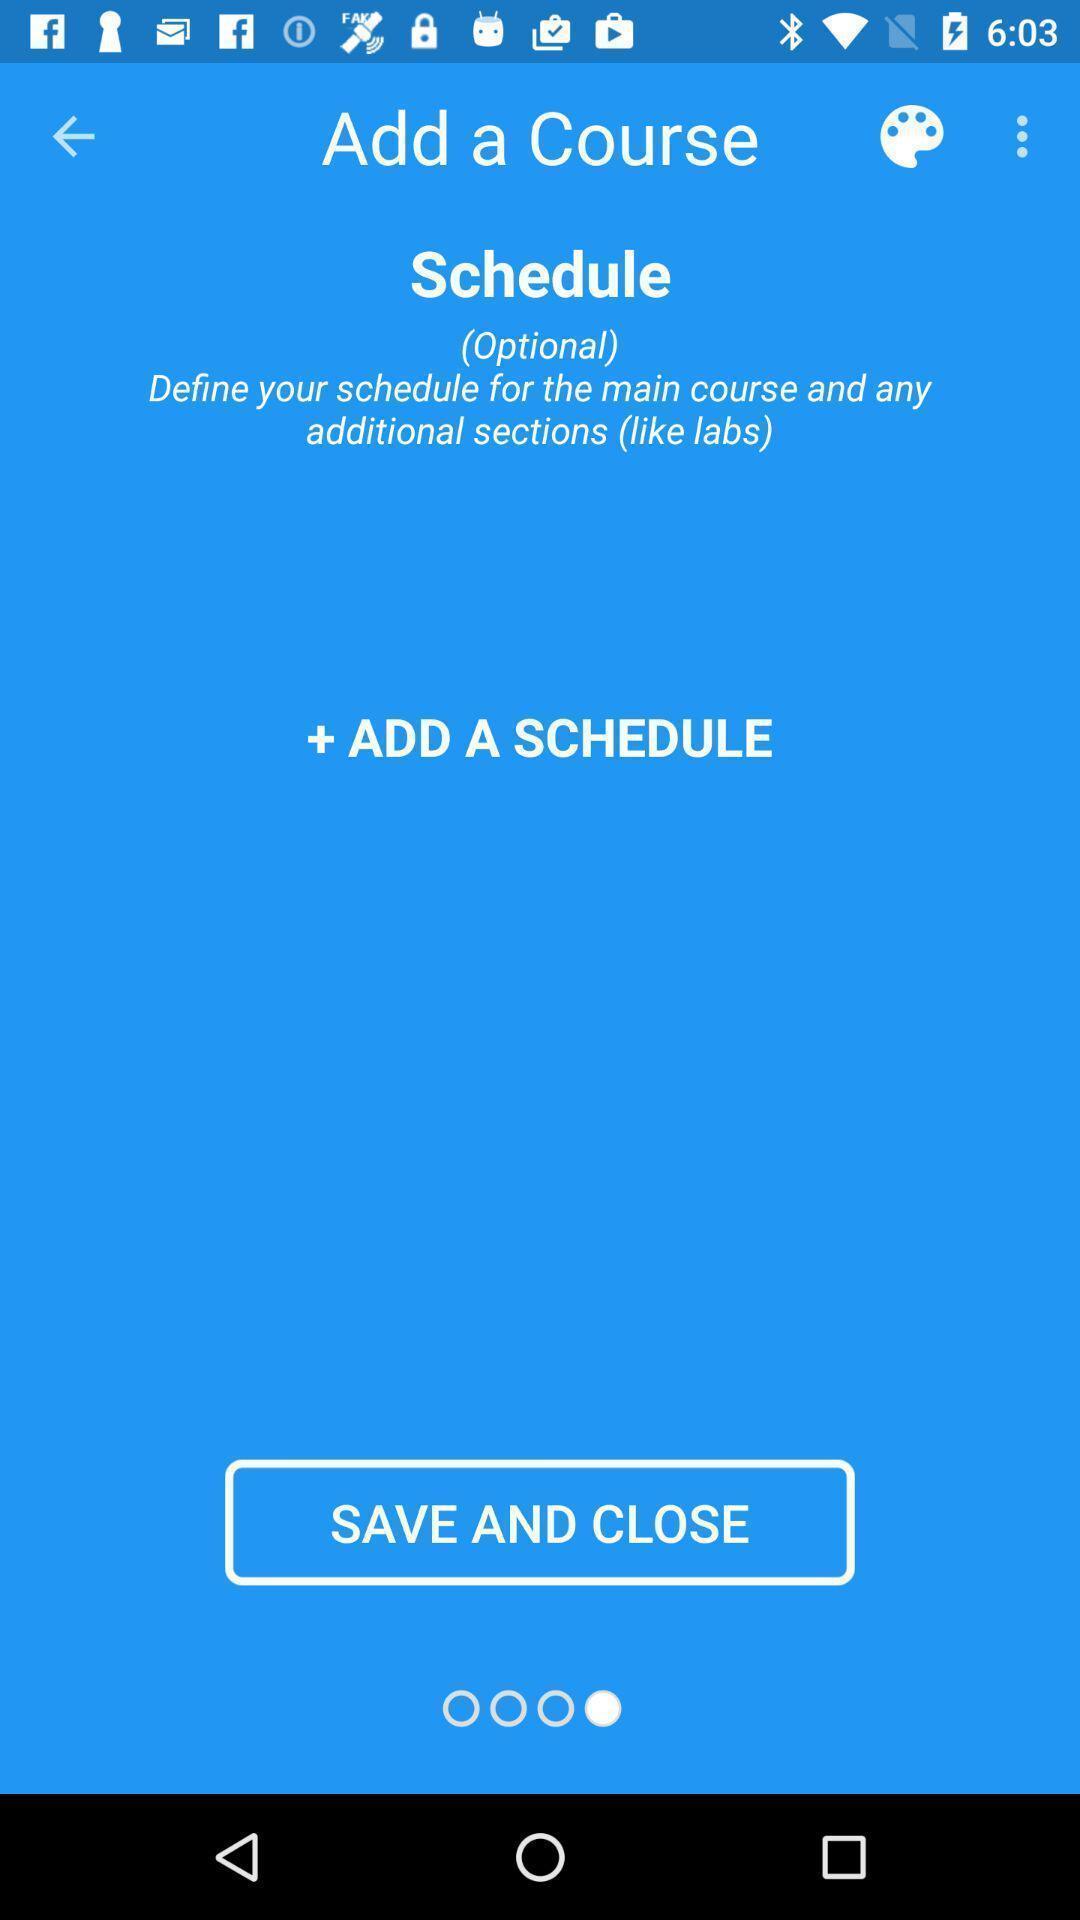Tell me about the visual elements in this screen capture. Screen shows add schedule details in a learning app. 